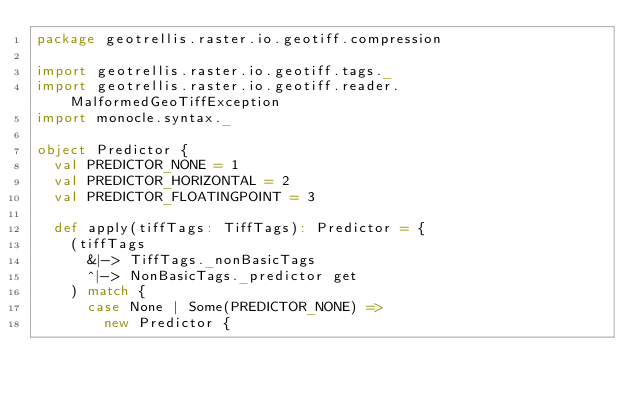<code> <loc_0><loc_0><loc_500><loc_500><_Scala_>package geotrellis.raster.io.geotiff.compression

import geotrellis.raster.io.geotiff.tags._
import geotrellis.raster.io.geotiff.reader.MalformedGeoTiffException
import monocle.syntax._

object Predictor {
  val PREDICTOR_NONE = 1
  val PREDICTOR_HORIZONTAL = 2
  val PREDICTOR_FLOATINGPOINT = 3

  def apply(tiffTags: TiffTags): Predictor = {
    (tiffTags
      &|-> TiffTags._nonBasicTags
      ^|-> NonBasicTags._predictor get
    ) match {
      case None | Some(PREDICTOR_NONE) => 
        new Predictor { </code> 